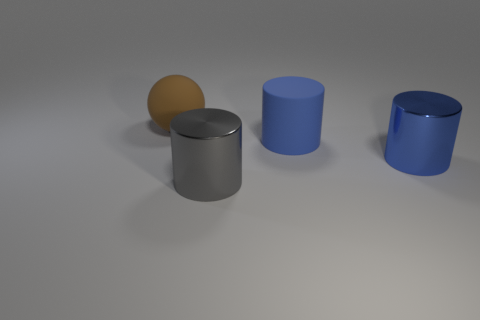What number of tiny purple matte cylinders are there?
Give a very brief answer. 0. How many things are either big matte things to the right of the brown matte object or matte things that are on the right side of the sphere?
Your response must be concise. 1. Do the matte object that is to the right of the gray metallic thing and the large brown matte object have the same size?
Provide a short and direct response. Yes. There is a blue matte thing that is the same shape as the blue metallic thing; what is its size?
Give a very brief answer. Large. There is another blue cylinder that is the same size as the rubber cylinder; what is it made of?
Provide a short and direct response. Metal. There is another large blue thing that is the same shape as the blue rubber thing; what material is it?
Provide a succinct answer. Metal. How many other things are the same size as the ball?
Give a very brief answer. 3. What is the size of the thing that is the same color as the big rubber cylinder?
Your answer should be compact. Large. How many shiny cylinders have the same color as the matte ball?
Keep it short and to the point. 0. The large brown thing is what shape?
Ensure brevity in your answer.  Sphere. 